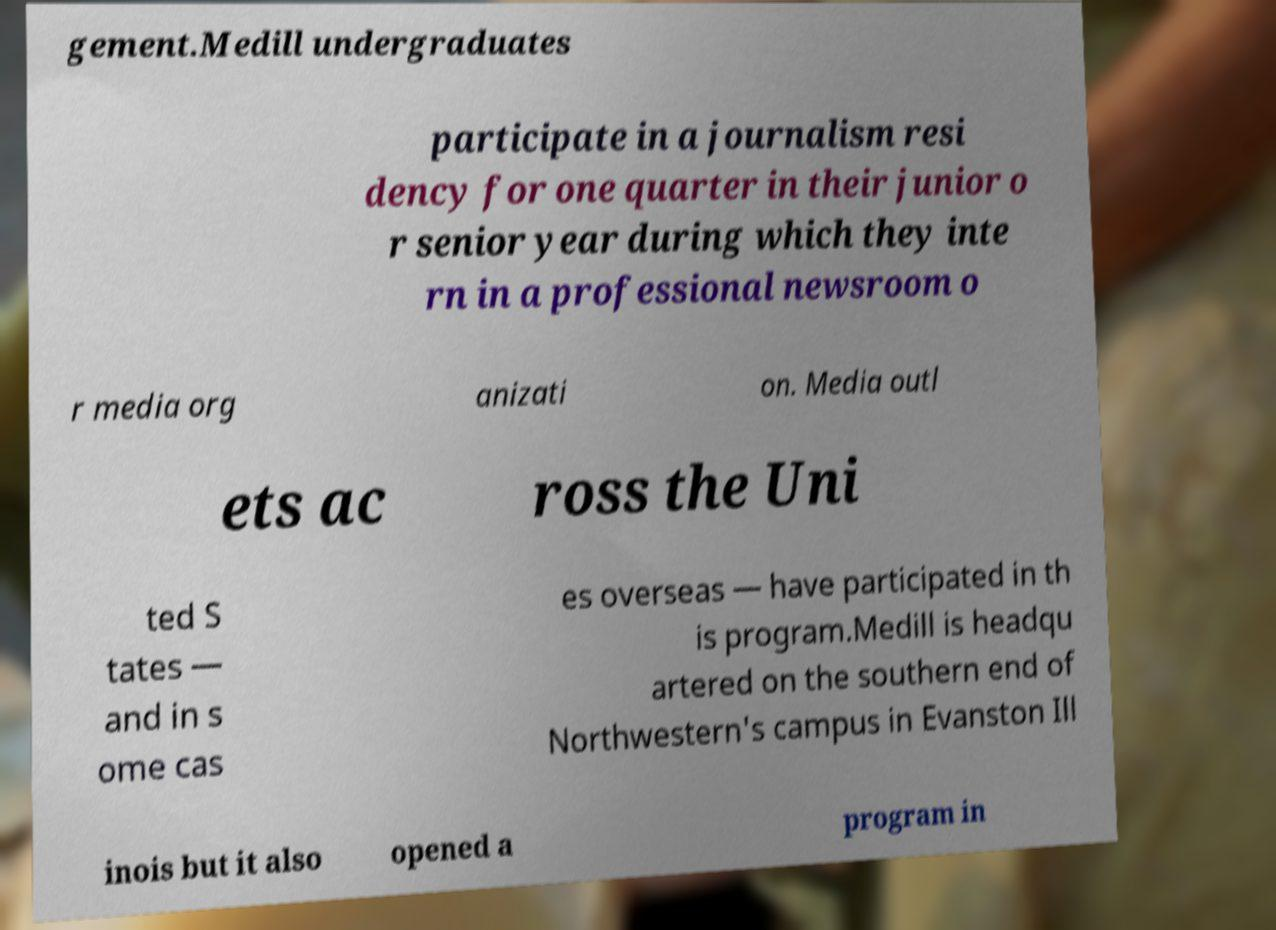For documentation purposes, I need the text within this image transcribed. Could you provide that? gement.Medill undergraduates participate in a journalism resi dency for one quarter in their junior o r senior year during which they inte rn in a professional newsroom o r media org anizati on. Media outl ets ac ross the Uni ted S tates — and in s ome cas es overseas — have participated in th is program.Medill is headqu artered on the southern end of Northwestern's campus in Evanston Ill inois but it also opened a program in 